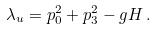<formula> <loc_0><loc_0><loc_500><loc_500>\lambda _ { u } = p ^ { 2 } _ { 0 } + p ^ { 2 } _ { 3 } - g H \, .</formula> 